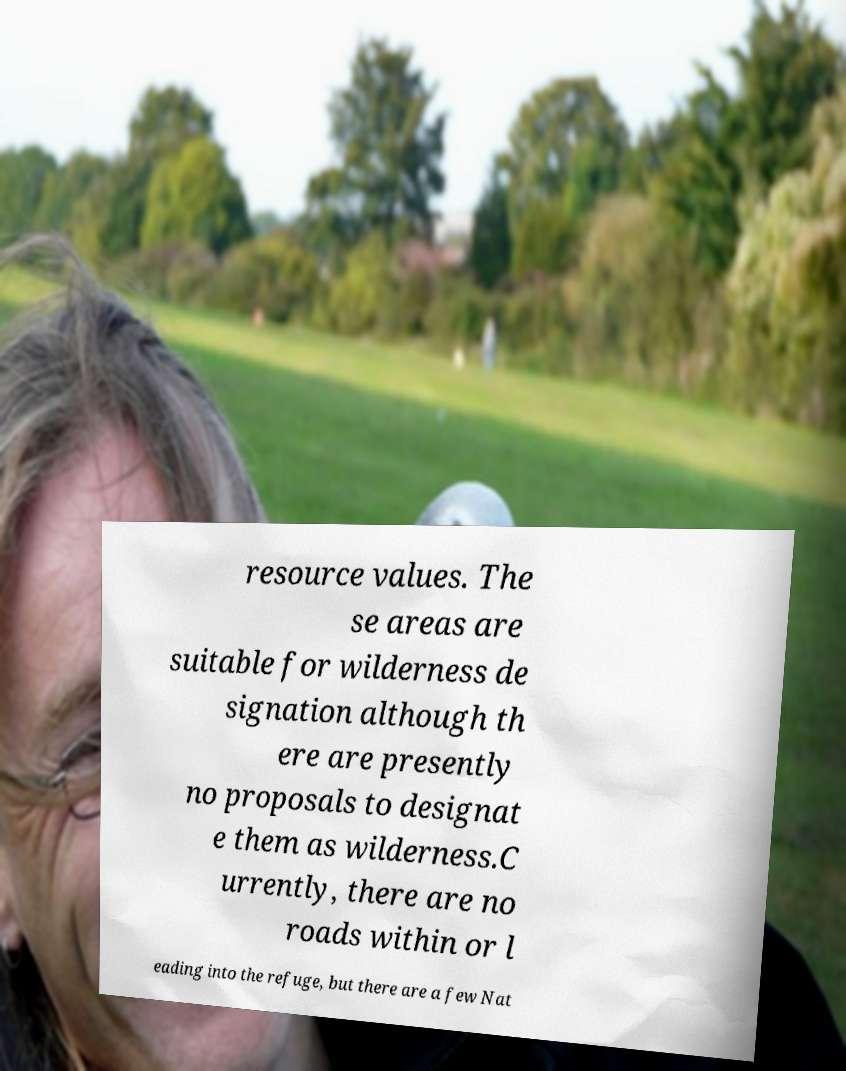Please read and relay the text visible in this image. What does it say? resource values. The se areas are suitable for wilderness de signation although th ere are presently no proposals to designat e them as wilderness.C urrently, there are no roads within or l eading into the refuge, but there are a few Nat 